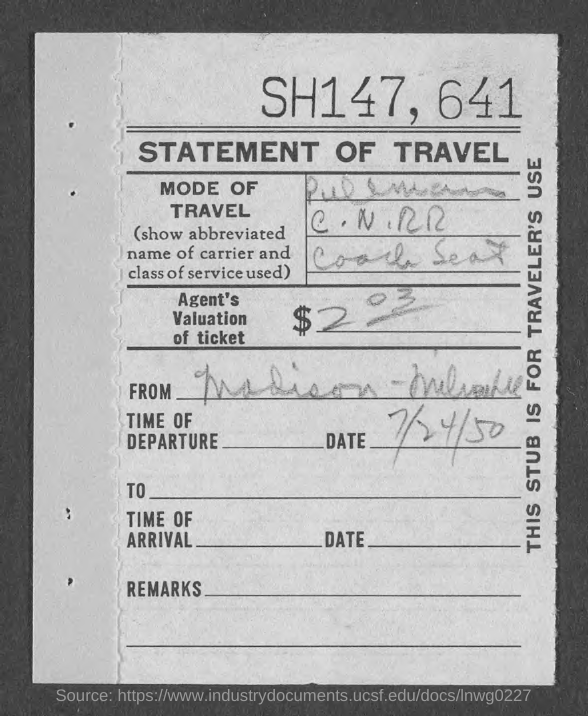What kind of statement is given here?
Provide a short and direct response. STATEMENT OF TRAVEL. What is the date of departure given in the statement?
Offer a very short reply. 7/24/50. How much is the Agent's valuation of ticket given in the statement?
Provide a succinct answer. $203. 